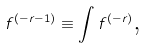<formula> <loc_0><loc_0><loc_500><loc_500>f ^ { \left ( - r - 1 \right ) } \equiv \int f ^ { \left ( - r \right ) } \text {,}</formula> 